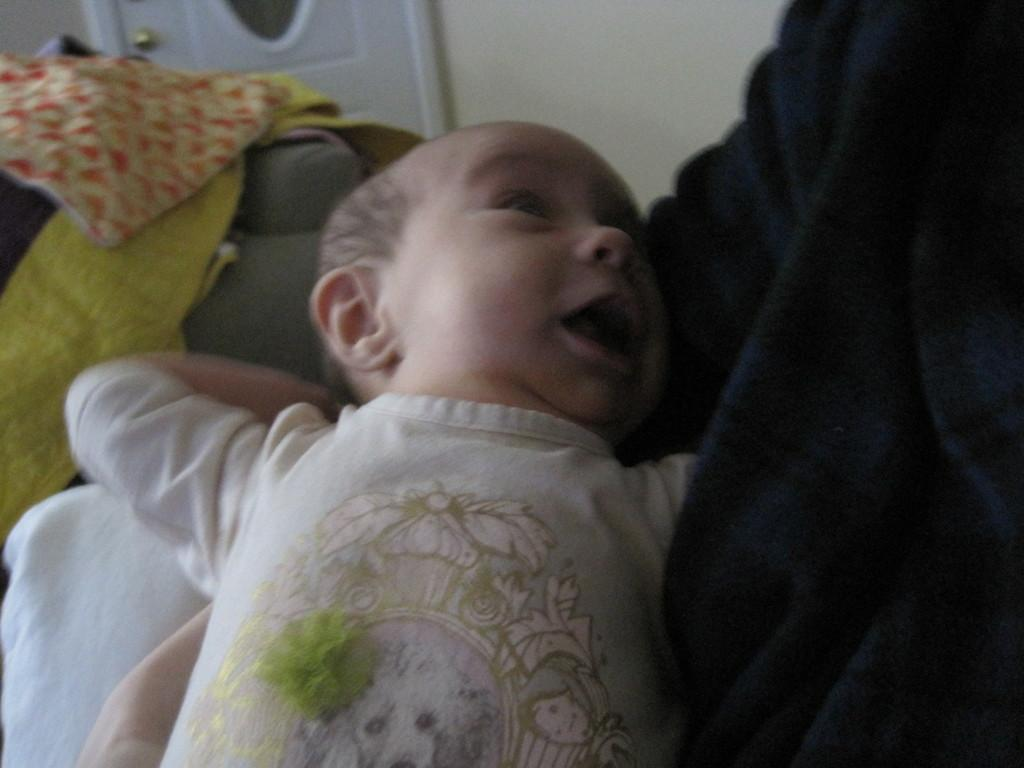Who is the main subject in the image? There is a boy in the image. What can be seen in the background of the image? There are clothes and a wall visible in the background of the image. What type of person is the boy biting in the image? There is no person being bitten in the image; the boy is the only person visible. 